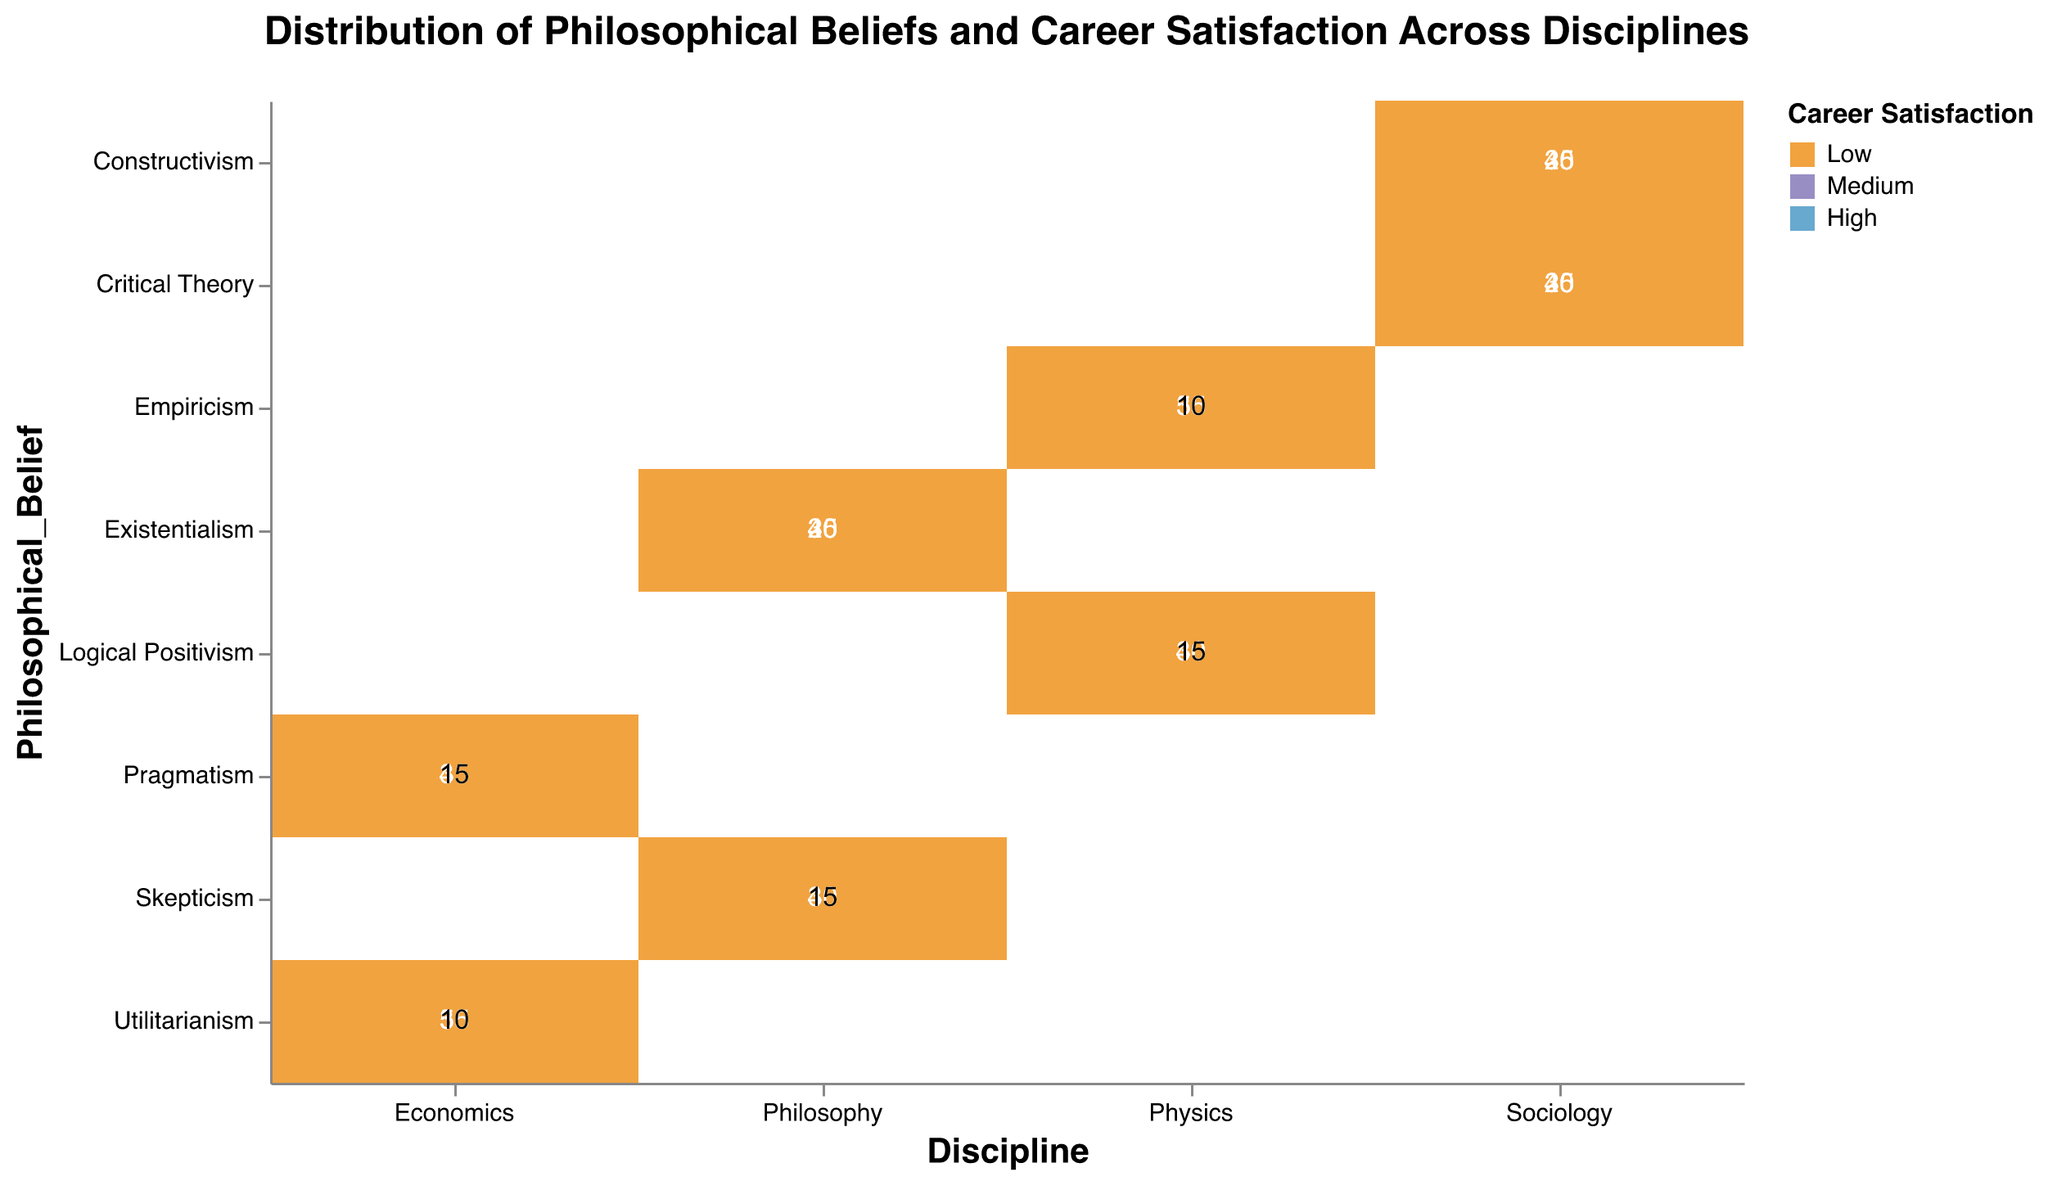What is the title of the mosaic plot? The title is usually centered at the top of the mosaic plot and describes the main subject or theme of the plot.
Answer: Distribution of Philosophical Beliefs and Career Satisfaction Across Disciplines Which discipline has the highest count of individuals with high career satisfaction in Utilitarianism? Look at the cells for Economics and count the color that represents high career satisfaction (likely a specific shade of blue) with Utilitarianism.
Answer: Economics How many individuals in Sociology report medium career satisfaction with Constructivism? Find the cell at the intersection of Sociology and Constructivism and look at the count for medium career satisfaction (typically a specific color).
Answer: 45 What is the total count of individuals in Physics with Logical Positivism as a belief? Sum the counts for high, medium, and low career satisfaction for Physics with Logical Positivism.
Answer: 85 Which philosophical belief in Philosophy has the highest total career satisfaction count? Sum the counts for high, medium, and low satisfaction for both Skepticism and Existentialism within Philosophy, then compare the totals.
Answer: Existentialism What is the difference in the number of individuals with high career satisfaction between Empiricism and Logical Positivism in Physics? Subtract the count of high career satisfaction in Logical Positivism within Physics from the count of high career satisfaction in Empiricism within Physics.
Answer: 10 Compare the proportions of high career satisfaction between Sociology and Economics for their respective dominant philosophical beliefs. Determine the philosophical belief in each discipline with the highest count in high career satisfaction, and then compare the numbers.
Answer: Economics has a higher proportion How many cells display a count below 20? Count all the cells within the plot where the numerical value is below 20.
Answer: 6 Is career satisfaction generally higher, medium, or lower in Philosophy for Skepticism versus Existentialism? Compare the counts of high, medium, and low career satisfaction between Skepticism and Existentialism in Philosophy.
Answer: Medium and High Does Economics show a higher total count of high career satisfaction individuals compared to Physics? Sum the counts of high career satisfaction individuals within Economics and Physics, and then compare the totals.
Answer: Yes 